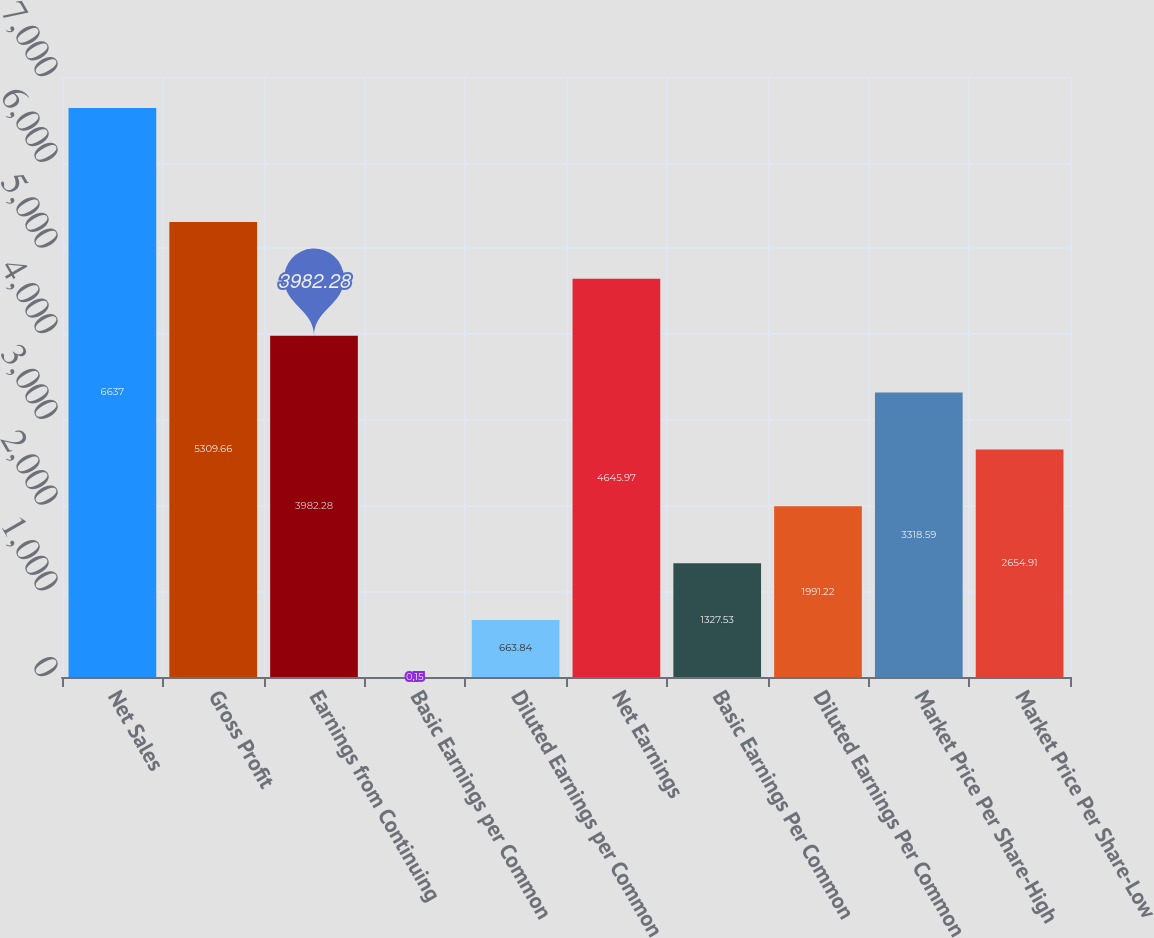Convert chart to OTSL. <chart><loc_0><loc_0><loc_500><loc_500><bar_chart><fcel>Net Sales<fcel>Gross Profit<fcel>Earnings from Continuing<fcel>Basic Earnings per Common<fcel>Diluted Earnings per Common<fcel>Net Earnings<fcel>Basic Earnings Per Common<fcel>Diluted Earnings Per Common<fcel>Market Price Per Share-High<fcel>Market Price Per Share-Low<nl><fcel>6637<fcel>5309.66<fcel>3982.28<fcel>0.15<fcel>663.84<fcel>4645.97<fcel>1327.53<fcel>1991.22<fcel>3318.59<fcel>2654.91<nl></chart> 